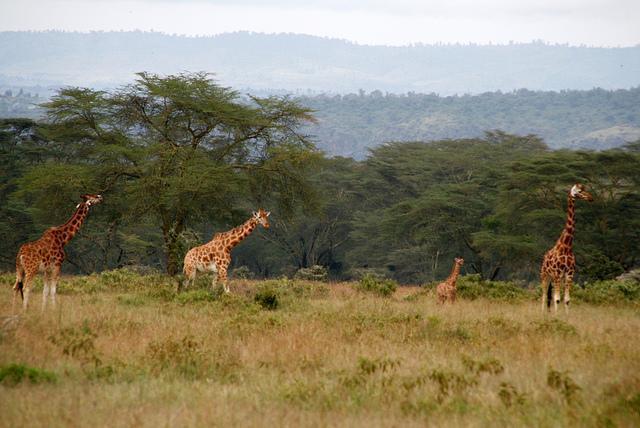How many elephants here?
Give a very brief answer. 0. How many giraffes are in the photo?
Give a very brief answer. 4. How many giraffes are there?
Give a very brief answer. 3. How many people wearing tennis shoes while holding a tennis racket are there? there are people not wearing tennis shoes while holding a tennis racket too?
Give a very brief answer. 0. 